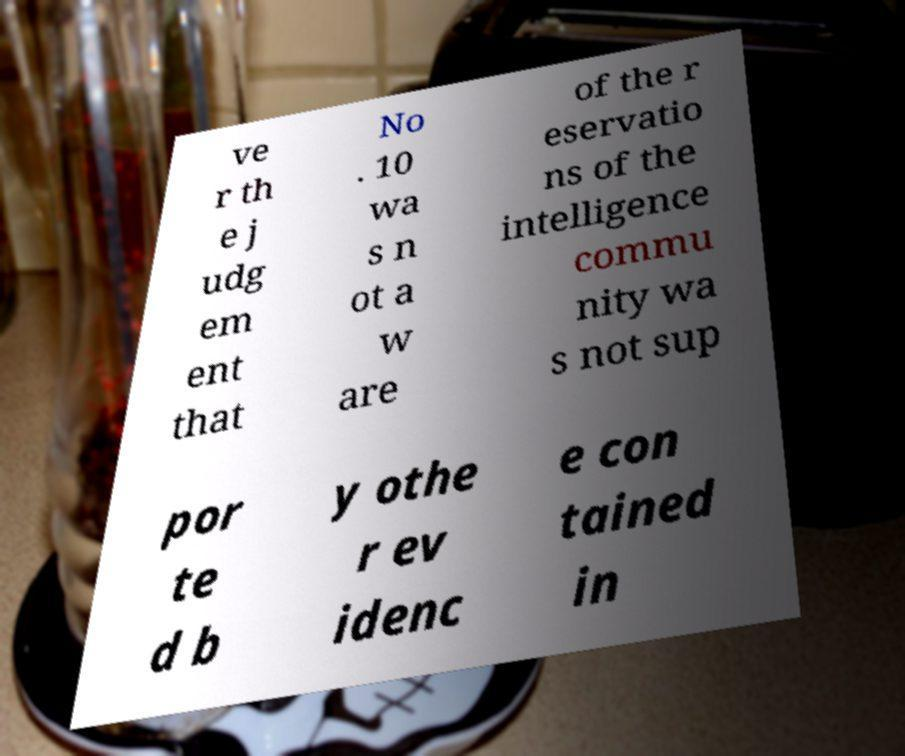There's text embedded in this image that I need extracted. Can you transcribe it verbatim? ve r th e j udg em ent that No . 10 wa s n ot a w are of the r eservatio ns of the intelligence commu nity wa s not sup por te d b y othe r ev idenc e con tained in 